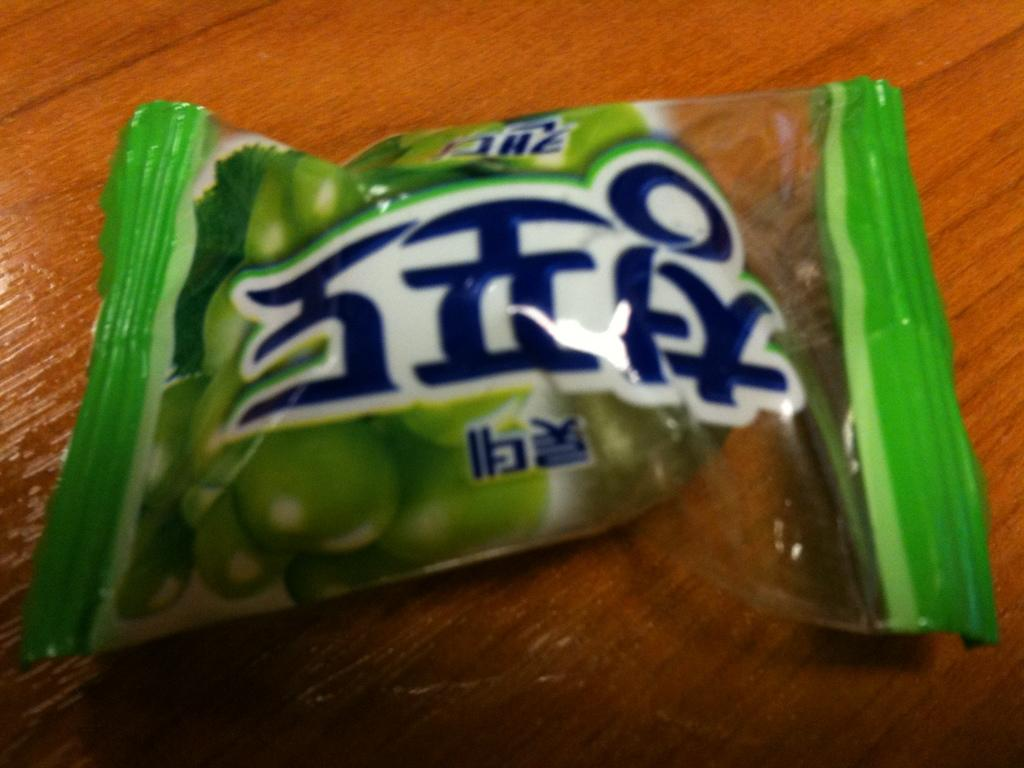<image>
Relay a brief, clear account of the picture shown. a bag with chinese writing on it for fruit 